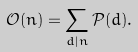Convert formula to latex. <formula><loc_0><loc_0><loc_500><loc_500>\mathcal { O } ( n ) = \sum _ { d | n } \mathcal { P } ( d ) .</formula> 